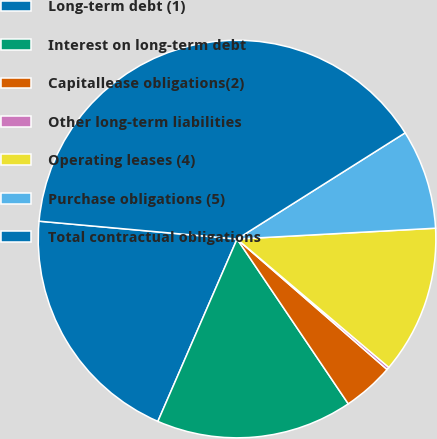<chart> <loc_0><loc_0><loc_500><loc_500><pie_chart><fcel>Long-term debt (1)<fcel>Interest on long-term debt<fcel>Capitallease obligations(2)<fcel>Other long-term liabilities<fcel>Operating leases (4)<fcel>Purchase obligations (5)<fcel>Total contractual obligations<nl><fcel>19.91%<fcel>15.97%<fcel>4.16%<fcel>0.22%<fcel>12.04%<fcel>8.1%<fcel>39.6%<nl></chart> 